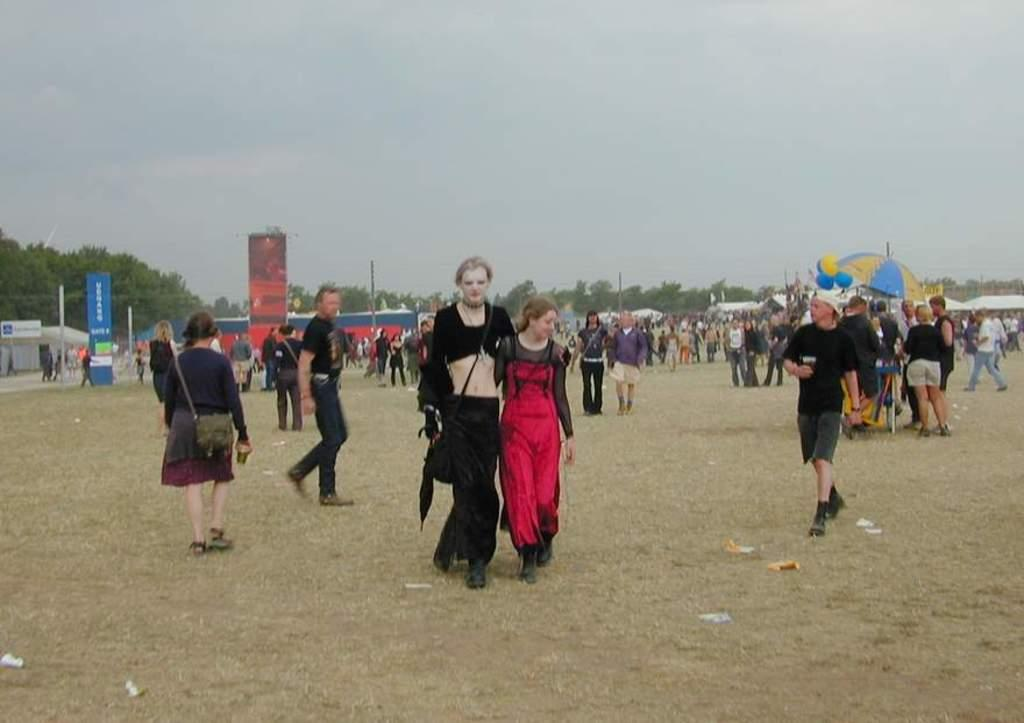How many people are in the image? There are people in the image, but the exact number is not specified. What are some of the people doing in the image? Some people are walking, and some are standing. What objects are visible in the image that can provide protection from the rain? Umbrellas are visible in the image. What decorative items can be seen in the image? Balloons are present in the image. What structures are visible in the background of the image? In the background, there are banners, poles, sheds, and trees. What part of the natural environment is visible in the background of the image? The sky is visible in the background. What type of alley can be seen in the image? There is no alley present in the image. 